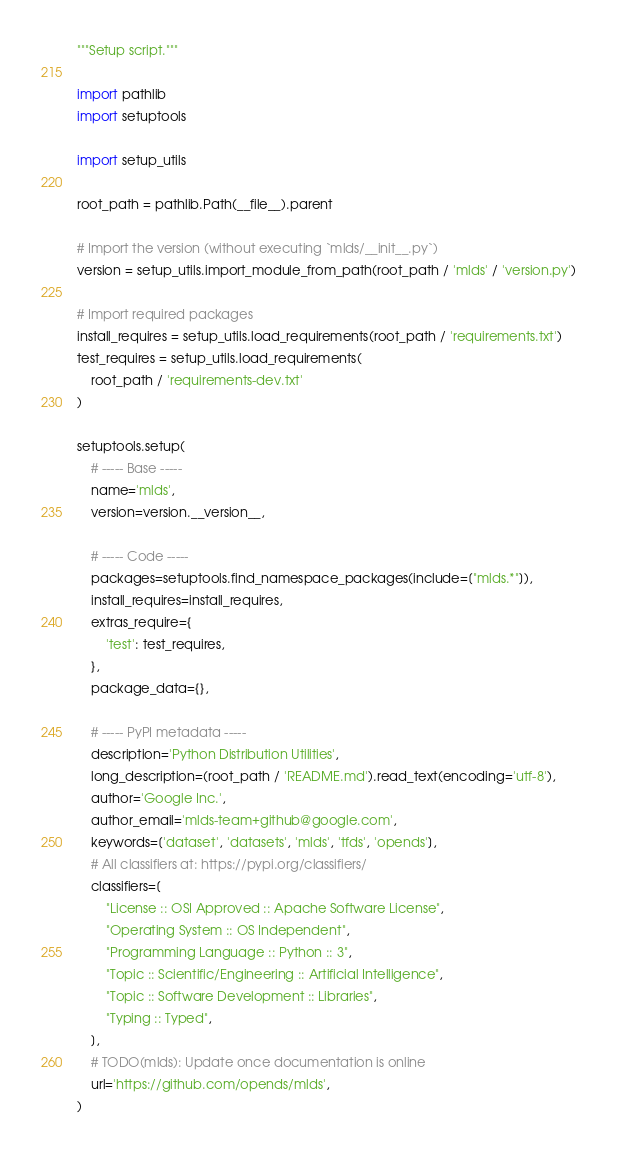Convert code to text. <code><loc_0><loc_0><loc_500><loc_500><_Python_>"""Setup script."""

import pathlib
import setuptools

import setup_utils

root_path = pathlib.Path(__file__).parent

# Import the version (without executing `mlds/__init__.py`)
version = setup_utils.import_module_from_path(root_path / 'mlds' / 'version.py')

# Import required packages
install_requires = setup_utils.load_requirements(root_path / 'requirements.txt')
test_requires = setup_utils.load_requirements(
    root_path / 'requirements-dev.txt'
)

setuptools.setup(
    # ----- Base -----
    name='mlds',
    version=version.__version__,

    # ----- Code -----
    packages=setuptools.find_namespace_packages(include=["mlds.*"]),
    install_requires=install_requires,
    extras_require={
        'test': test_requires,
    },
    package_data={},

    # ----- PyPI metadata -----
    description='Python Distribution Utilities',
    long_description=(root_path / 'README.md').read_text(encoding='utf-8'),
    author='Google Inc.',
    author_email='mlds-team+github@google.com',
    keywords=['dataset', 'datasets', 'mlds', 'tfds', 'opends'],
    # All classifiers at: https://pypi.org/classifiers/
    classifiers=[
        "License :: OSI Approved :: Apache Software License",
        "Operating System :: OS Independent",
        "Programming Language :: Python :: 3",
        "Topic :: Scientific/Engineering :: Artificial Intelligence",
        "Topic :: Software Development :: Libraries",
        "Typing :: Typed",
    ],
    # TODO(mlds): Update once documentation is online
    url='https://github.com/opends/mlds',
)
</code> 